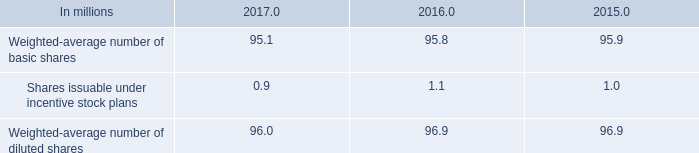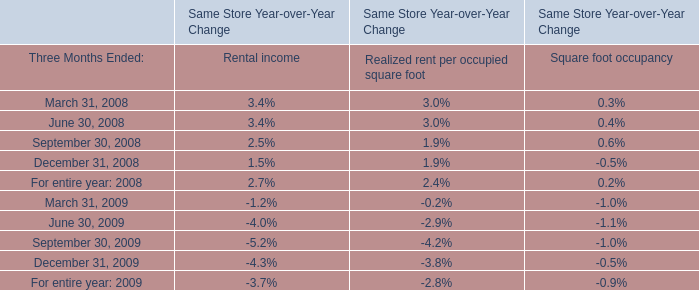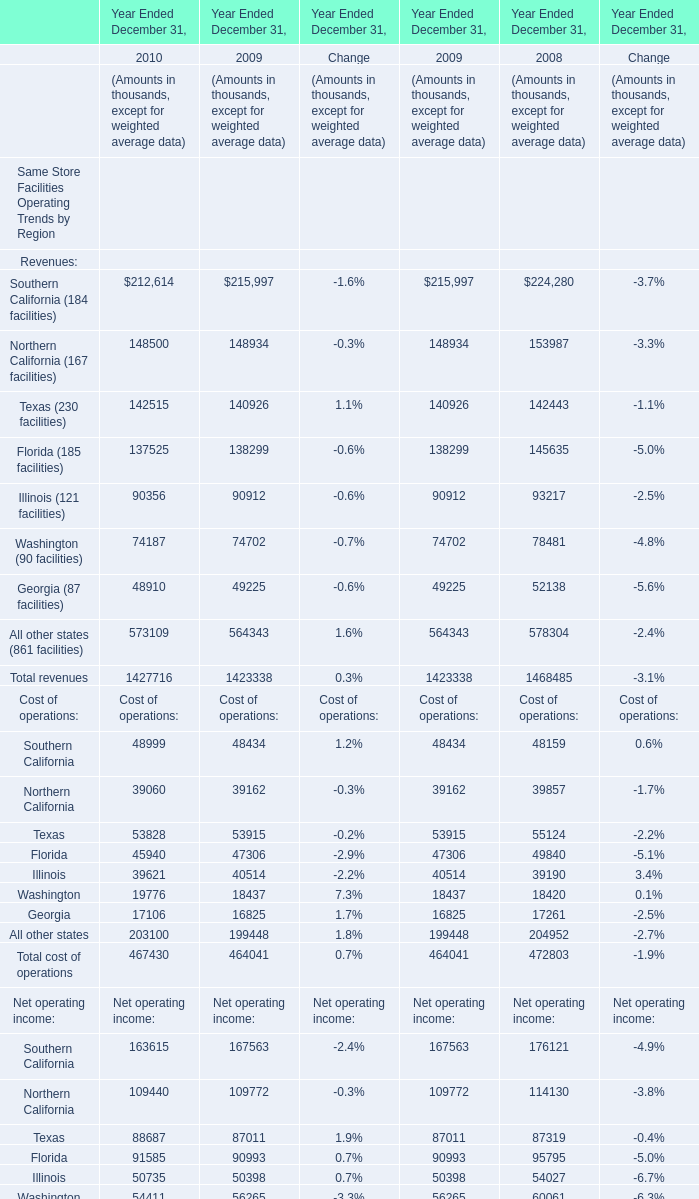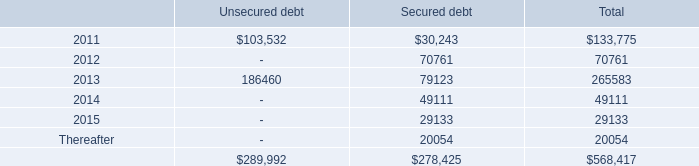what is the percentual decrease observed in the reserves for environmental matters during 2016 and 2017? 
Computations: (((28.9 - 30.6) / 30.6) * 100)
Answer: -5.55556. 